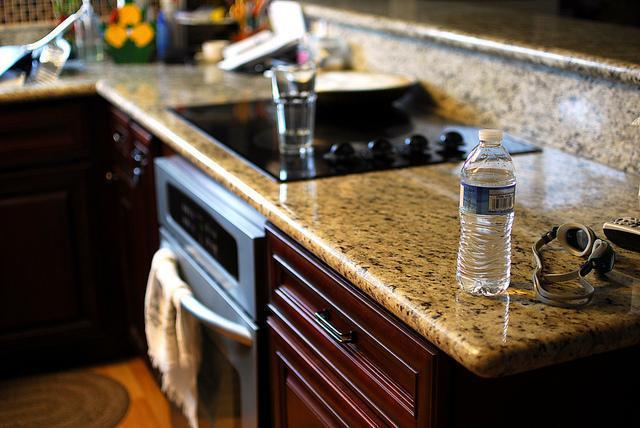How many bottles?
Give a very brief answer. 1. How many people are wearing baseball hats?
Give a very brief answer. 0. 